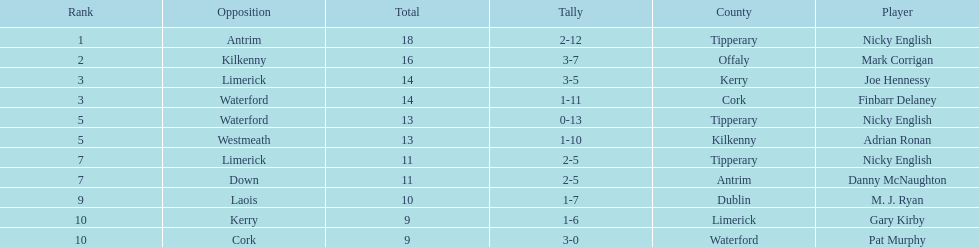Joe hennessy and finbarr delaney both scored how many points? 14. 